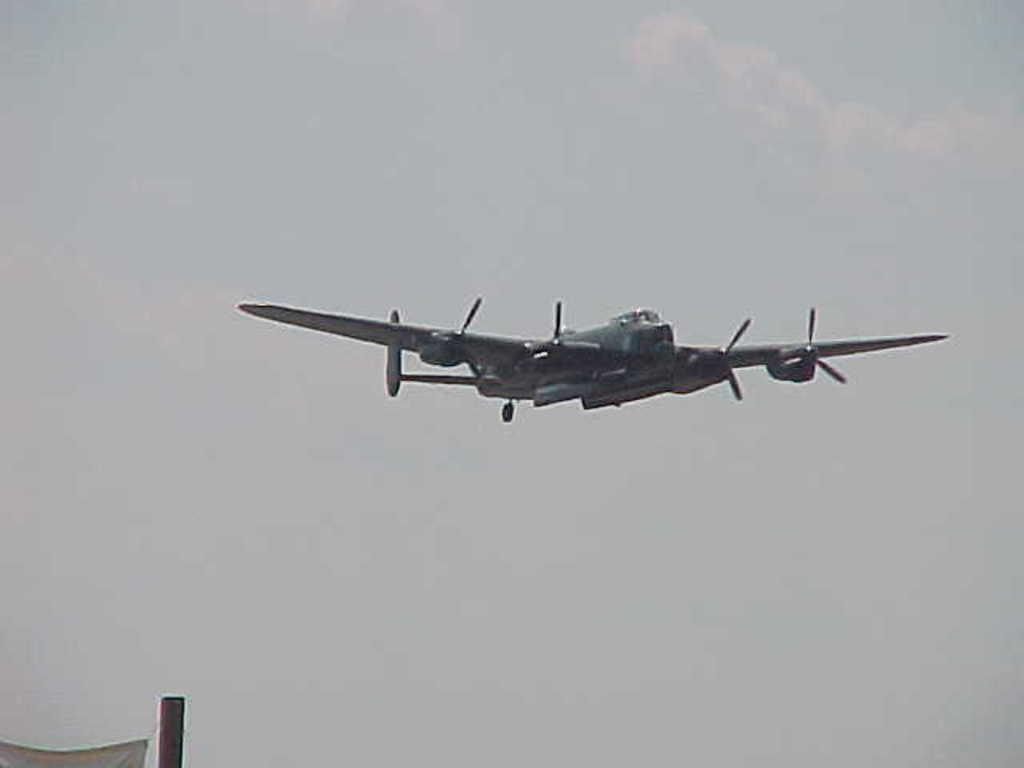What is the main subject of the image? The main subject of the image is an aircraft. What is the aircraft doing in the image? The aircraft is flying in the air. What can be seen in the background of the image? The sky is visible in the image. What is the color of the sky in the image? The color of the sky is white. What type of wrench is being used to adjust the aircraft's territory in the image? There is no wrench or territory adjustment present in the image; it only features an aircraft flying in the sky. 